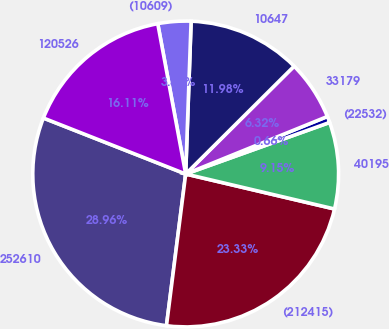Convert chart. <chart><loc_0><loc_0><loc_500><loc_500><pie_chart><fcel>252610<fcel>(212415)<fcel>40195<fcel>(22532)<fcel>33179<fcel>10647<fcel>(10609)<fcel>120526<nl><fcel>28.96%<fcel>23.33%<fcel>9.15%<fcel>0.66%<fcel>6.32%<fcel>11.98%<fcel>3.49%<fcel>16.11%<nl></chart> 